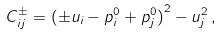Convert formula to latex. <formula><loc_0><loc_0><loc_500><loc_500>C _ { i j } ^ { \pm } = { ( \pm u _ { i } - p ^ { 0 } _ { i } + p ^ { 0 } _ { j } ) } ^ { 2 } - u _ { j } ^ { 2 } \, ,</formula> 